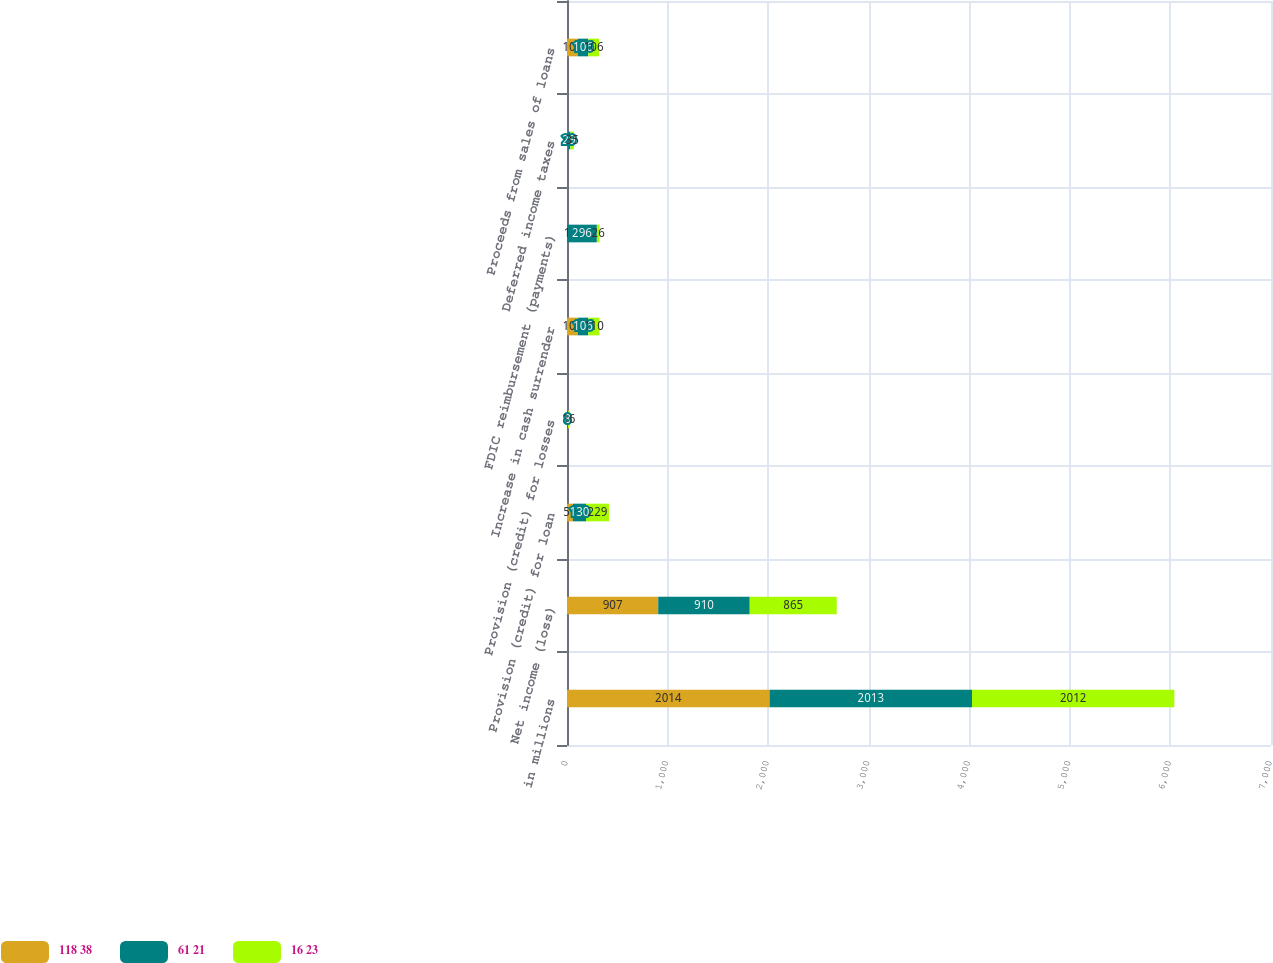Convert chart to OTSL. <chart><loc_0><loc_0><loc_500><loc_500><stacked_bar_chart><ecel><fcel>in millions<fcel>Net income (loss)<fcel>Provision (credit) for loan<fcel>Provision (credit) for losses<fcel>Increase in cash surrender<fcel>FDIC reimbursement (payments)<fcel>Deferred income taxes<fcel>Proceeds from sales of loans<nl><fcel>118 38<fcel>2014<fcel>907<fcel>59<fcel>2<fcel>106<fcel>1<fcel>5<fcel>106<nl><fcel>61 21<fcel>2013<fcel>910<fcel>130<fcel>8<fcel>106<fcel>296<fcel>29<fcel>106<nl><fcel>16 23<fcel>2012<fcel>865<fcel>229<fcel>16<fcel>110<fcel>26<fcel>35<fcel>106<nl></chart> 